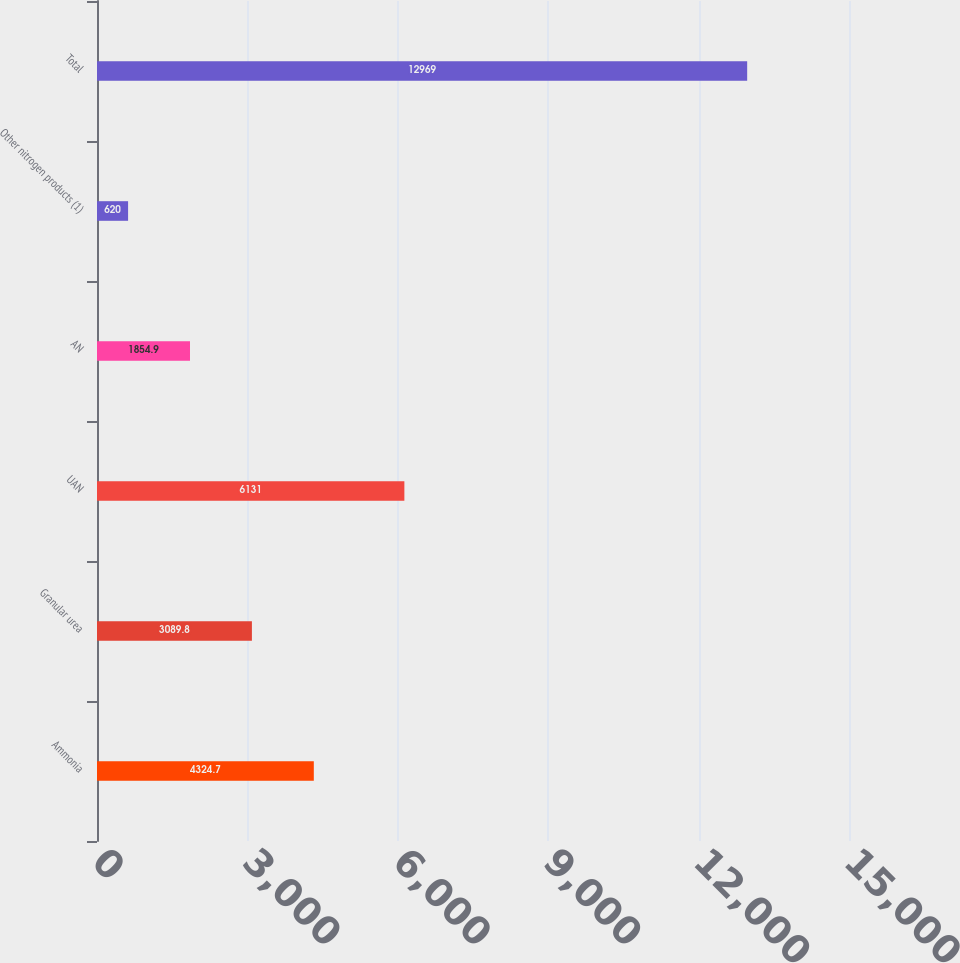Convert chart. <chart><loc_0><loc_0><loc_500><loc_500><bar_chart><fcel>Ammonia<fcel>Granular urea<fcel>UAN<fcel>AN<fcel>Other nitrogen products (1)<fcel>Total<nl><fcel>4324.7<fcel>3089.8<fcel>6131<fcel>1854.9<fcel>620<fcel>12969<nl></chart> 